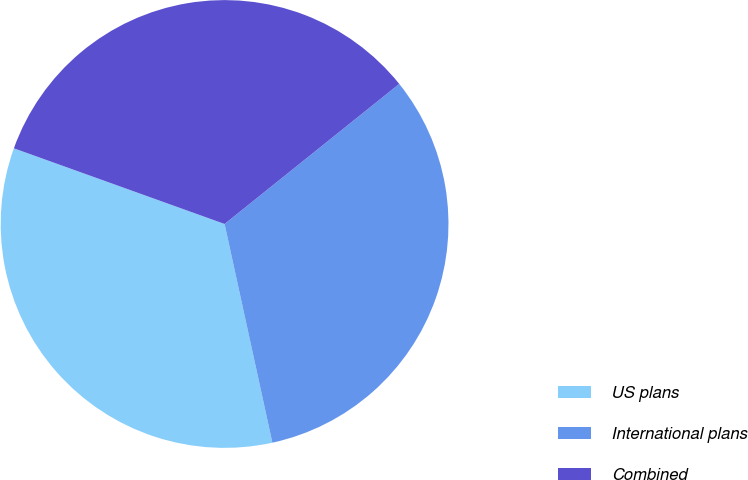Convert chart. <chart><loc_0><loc_0><loc_500><loc_500><pie_chart><fcel>US plans<fcel>International plans<fcel>Combined<nl><fcel>33.91%<fcel>32.33%<fcel>33.75%<nl></chart> 